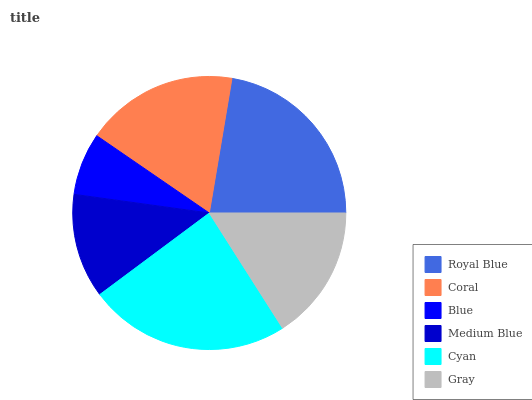Is Blue the minimum?
Answer yes or no. Yes. Is Cyan the maximum?
Answer yes or no. Yes. Is Coral the minimum?
Answer yes or no. No. Is Coral the maximum?
Answer yes or no. No. Is Royal Blue greater than Coral?
Answer yes or no. Yes. Is Coral less than Royal Blue?
Answer yes or no. Yes. Is Coral greater than Royal Blue?
Answer yes or no. No. Is Royal Blue less than Coral?
Answer yes or no. No. Is Coral the high median?
Answer yes or no. Yes. Is Gray the low median?
Answer yes or no. Yes. Is Cyan the high median?
Answer yes or no. No. Is Coral the low median?
Answer yes or no. No. 